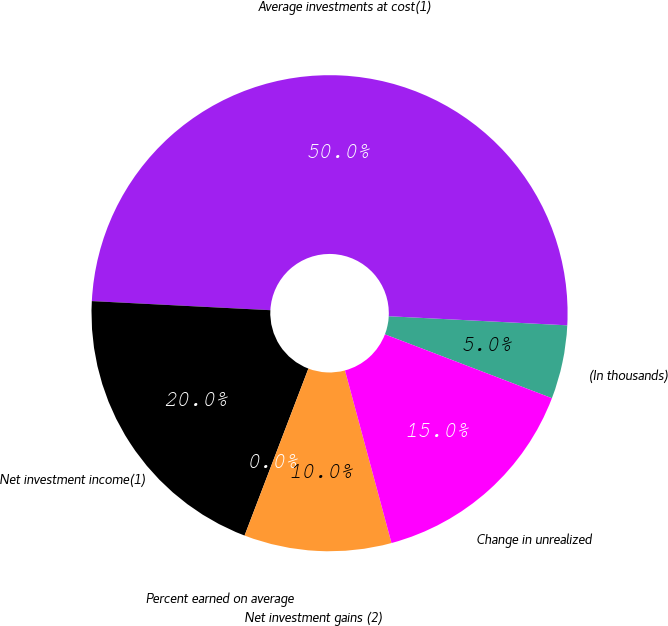Convert chart to OTSL. <chart><loc_0><loc_0><loc_500><loc_500><pie_chart><fcel>(In thousands)<fcel>Average investments at cost(1)<fcel>Net investment income(1)<fcel>Percent earned on average<fcel>Net investment gains (2)<fcel>Change in unrealized<nl><fcel>5.0%<fcel>50.0%<fcel>20.0%<fcel>0.0%<fcel>10.0%<fcel>15.0%<nl></chart> 